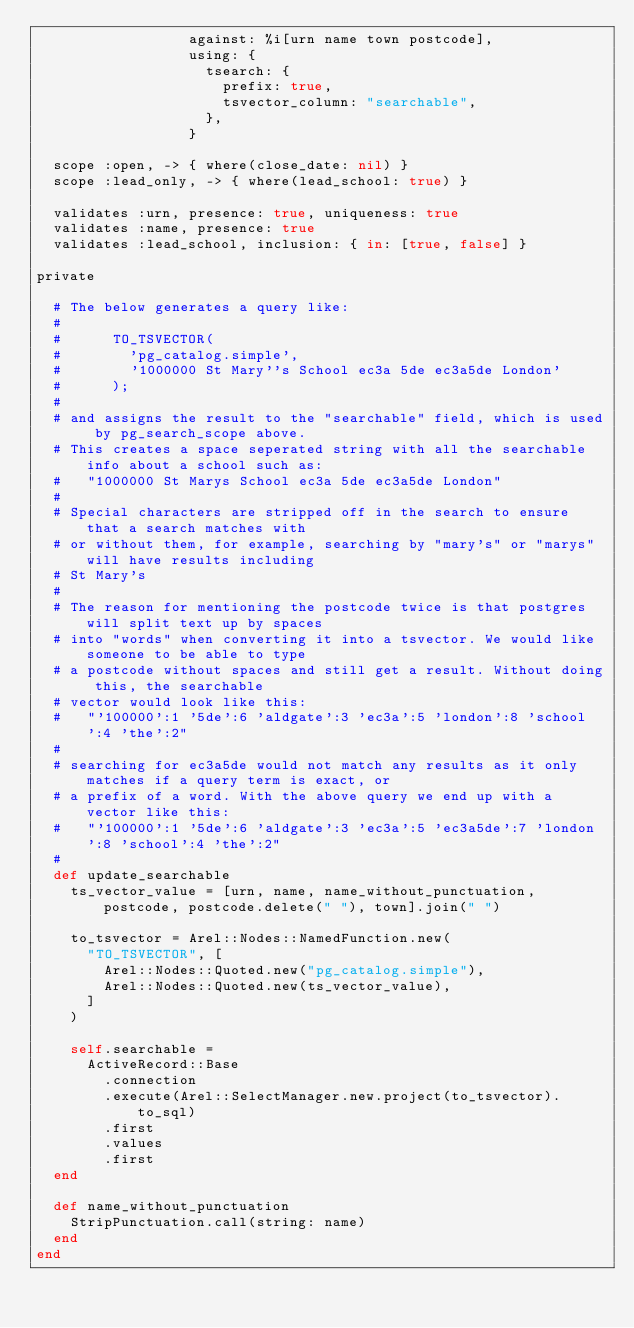<code> <loc_0><loc_0><loc_500><loc_500><_Ruby_>                  against: %i[urn name town postcode],
                  using: {
                    tsearch: {
                      prefix: true,
                      tsvector_column: "searchable",
                    },
                  }

  scope :open, -> { where(close_date: nil) }
  scope :lead_only, -> { where(lead_school: true) }

  validates :urn, presence: true, uniqueness: true
  validates :name, presence: true
  validates :lead_school, inclusion: { in: [true, false] }

private

  # The below generates a query like:
  #
  #      TO_TSVECTOR(
  #        'pg_catalog.simple',
  #        '1000000 St Mary''s School ec3a 5de ec3a5de London'
  #      );
  #
  # and assigns the result to the "searchable" field, which is used by pg_search_scope above.
  # This creates a space seperated string with all the searchable info about a school such as:
  #   "1000000 St Marys School ec3a 5de ec3a5de London"
  #
  # Special characters are stripped off in the search to ensure that a search matches with
  # or without them, for example, searching by "mary's" or "marys" will have results including
  # St Mary's
  #
  # The reason for mentioning the postcode twice is that postgres will split text up by spaces
  # into "words" when converting it into a tsvector. We would like someone to be able to type
  # a postcode without spaces and still get a result. Without doing this, the searchable
  # vector would look like this:
  #   "'100000':1 '5de':6 'aldgate':3 'ec3a':5 'london':8 'school':4 'the':2"
  #
  # searching for ec3a5de would not match any results as it only matches if a query term is exact, or
  # a prefix of a word. With the above query we end up with a vector like this:
  #   "'100000':1 '5de':6 'aldgate':3 'ec3a':5 'ec3a5de':7 'london':8 'school':4 'the':2"
  #
  def update_searchable
    ts_vector_value = [urn, name, name_without_punctuation, postcode, postcode.delete(" "), town].join(" ")

    to_tsvector = Arel::Nodes::NamedFunction.new(
      "TO_TSVECTOR", [
        Arel::Nodes::Quoted.new("pg_catalog.simple"),
        Arel::Nodes::Quoted.new(ts_vector_value),
      ]
    )

    self.searchable =
      ActiveRecord::Base
        .connection
        .execute(Arel::SelectManager.new.project(to_tsvector).to_sql)
        .first
        .values
        .first
  end

  def name_without_punctuation
    StripPunctuation.call(string: name)
  end
end
</code> 